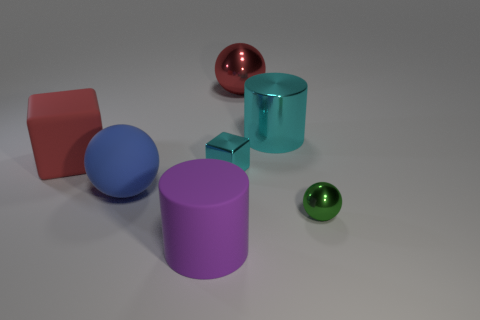What color is the big shiny cylinder?
Offer a very short reply. Cyan. Is the number of red objects greater than the number of big red rubber blocks?
Your answer should be compact. Yes. How many things are either cylinders that are in front of the big shiny cylinder or metal cylinders?
Provide a short and direct response. 2. Do the purple cylinder and the green object have the same material?
Your answer should be very brief. No. There is a red thing that is the same shape as the big blue matte thing; what size is it?
Your answer should be very brief. Large. Do the tiny thing that is behind the green thing and the red matte object behind the cyan block have the same shape?
Offer a terse response. Yes. Is the size of the blue thing the same as the cylinder that is to the left of the big red sphere?
Your response must be concise. Yes. What number of other things are there of the same material as the cyan cylinder
Give a very brief answer. 3. Is there any other thing that is the same shape as the red shiny thing?
Give a very brief answer. Yes. What color is the ball behind the ball that is to the left of the cyan metallic thing in front of the red block?
Offer a very short reply. Red. 